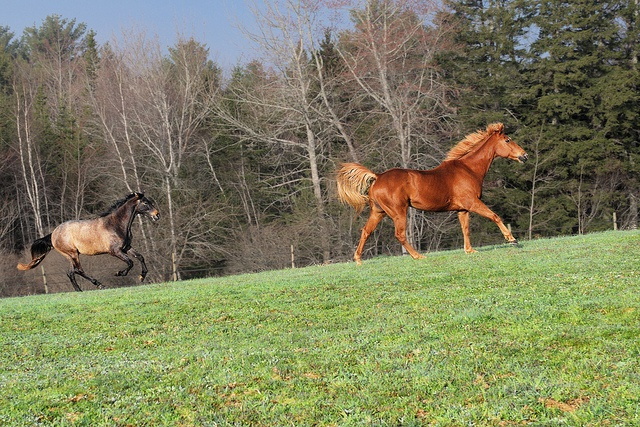Describe the objects in this image and their specific colors. I can see horse in lightblue, brown, tan, and maroon tones and horse in lightblue, black, gray, and tan tones in this image. 